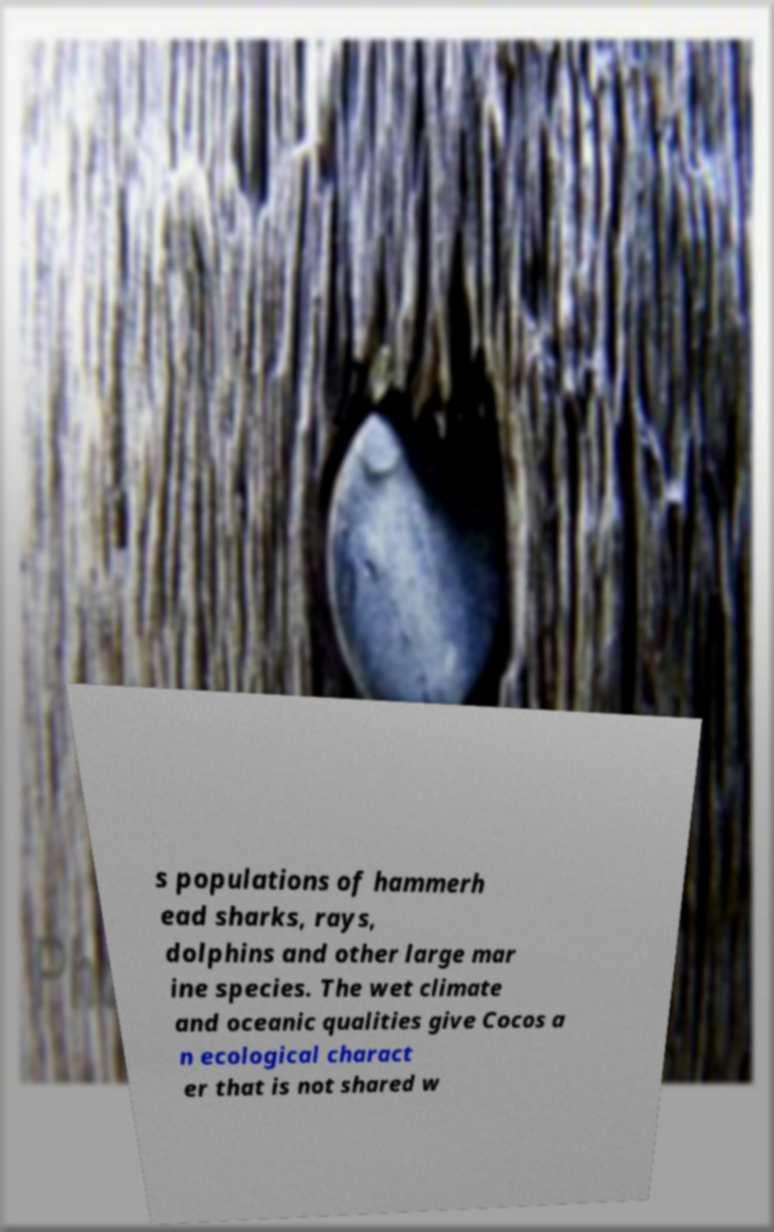Can you read and provide the text displayed in the image?This photo seems to have some interesting text. Can you extract and type it out for me? s populations of hammerh ead sharks, rays, dolphins and other large mar ine species. The wet climate and oceanic qualities give Cocos a n ecological charact er that is not shared w 